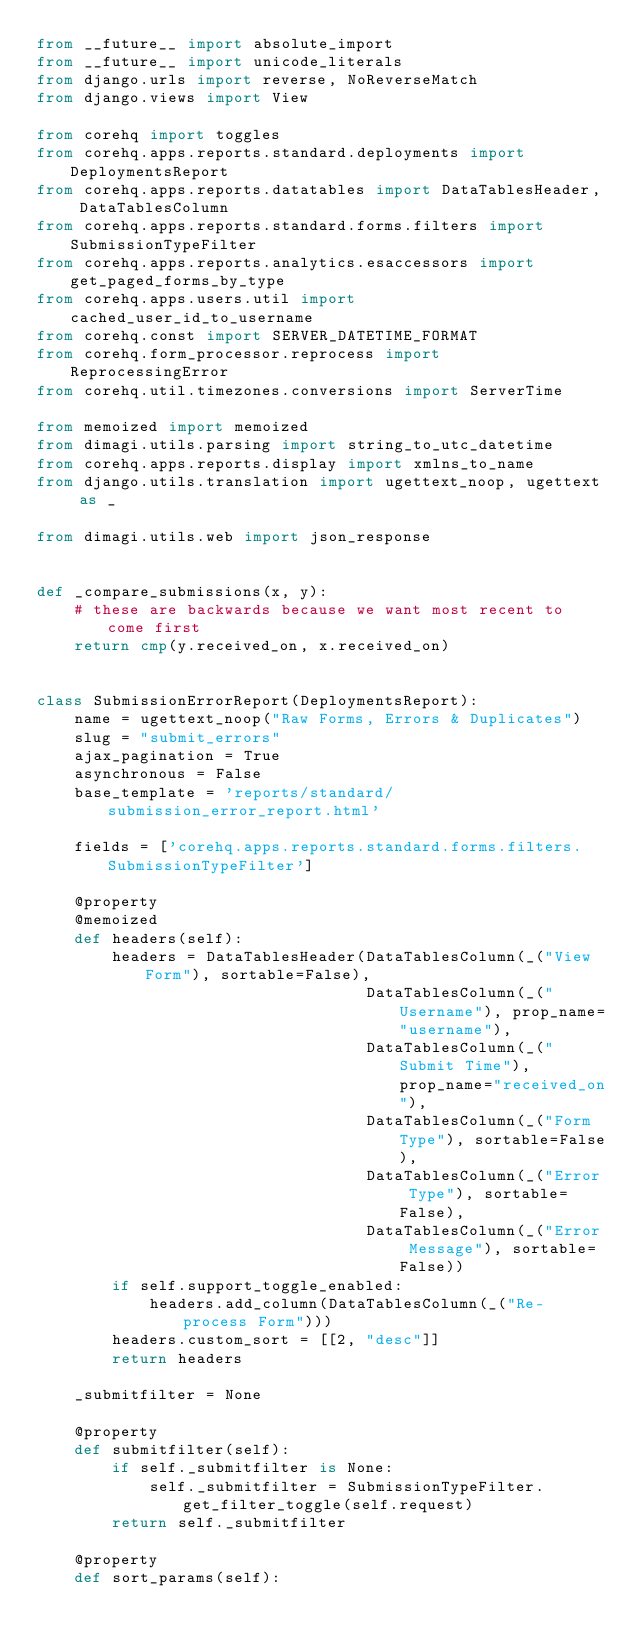<code> <loc_0><loc_0><loc_500><loc_500><_Python_>from __future__ import absolute_import
from __future__ import unicode_literals
from django.urls import reverse, NoReverseMatch
from django.views import View

from corehq import toggles
from corehq.apps.reports.standard.deployments import DeploymentsReport
from corehq.apps.reports.datatables import DataTablesHeader, DataTablesColumn
from corehq.apps.reports.standard.forms.filters import SubmissionTypeFilter
from corehq.apps.reports.analytics.esaccessors import get_paged_forms_by_type
from corehq.apps.users.util import cached_user_id_to_username
from corehq.const import SERVER_DATETIME_FORMAT
from corehq.form_processor.reprocess import ReprocessingError
from corehq.util.timezones.conversions import ServerTime

from memoized import memoized
from dimagi.utils.parsing import string_to_utc_datetime
from corehq.apps.reports.display import xmlns_to_name
from django.utils.translation import ugettext_noop, ugettext as _

from dimagi.utils.web import json_response


def _compare_submissions(x, y):
    # these are backwards because we want most recent to come first
    return cmp(y.received_on, x.received_on)


class SubmissionErrorReport(DeploymentsReport):
    name = ugettext_noop("Raw Forms, Errors & Duplicates")
    slug = "submit_errors"
    ajax_pagination = True
    asynchronous = False
    base_template = 'reports/standard/submission_error_report.html'

    fields = ['corehq.apps.reports.standard.forms.filters.SubmissionTypeFilter']

    @property
    @memoized
    def headers(self):
        headers = DataTablesHeader(DataTablesColumn(_("View Form"), sortable=False),
                                   DataTablesColumn(_("Username"), prop_name="username"),
                                   DataTablesColumn(_("Submit Time"), prop_name="received_on"),
                                   DataTablesColumn(_("Form Type"), sortable=False),
                                   DataTablesColumn(_("Error Type"), sortable=False),
                                   DataTablesColumn(_("Error Message"), sortable=False))
        if self.support_toggle_enabled:
            headers.add_column(DataTablesColumn(_("Re-process Form")))
        headers.custom_sort = [[2, "desc"]]
        return headers

    _submitfilter = None

    @property
    def submitfilter(self):
        if self._submitfilter is None:
            self._submitfilter = SubmissionTypeFilter.get_filter_toggle(self.request)
        return self._submitfilter

    @property
    def sort_params(self):</code> 